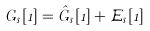Convert formula to latex. <formula><loc_0><loc_0><loc_500><loc_500>G _ { s } [ 1 ] = \hat { G } _ { s } [ 1 ] + \mathcal { E } _ { s } [ 1 ]</formula> 